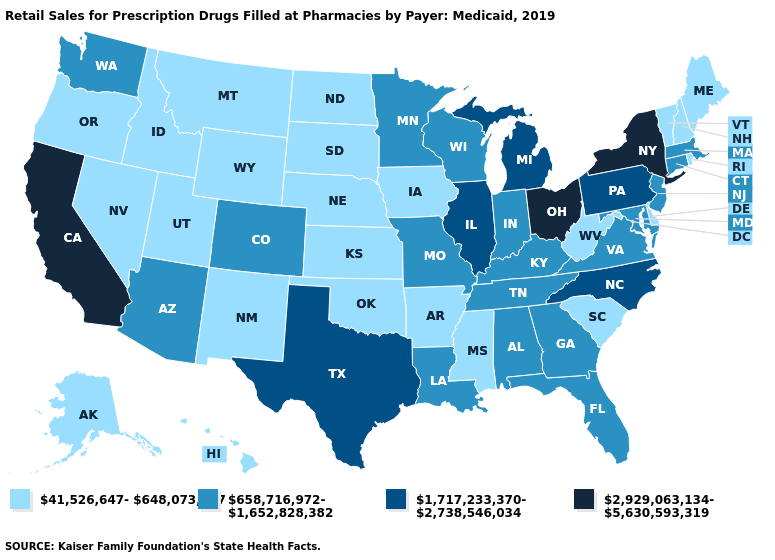Among the states that border Colorado , does Arizona have the highest value?
Quick response, please. Yes. Does South Carolina have the lowest value in the South?
Concise answer only. Yes. Which states have the highest value in the USA?
Keep it brief. California, New York, Ohio. What is the value of North Carolina?
Short answer required. 1,717,233,370-2,738,546,034. Which states have the highest value in the USA?
Keep it brief. California, New York, Ohio. Does New Mexico have a higher value than North Carolina?
Quick response, please. No. Among the states that border Colorado , which have the lowest value?
Keep it brief. Kansas, Nebraska, New Mexico, Oklahoma, Utah, Wyoming. Name the states that have a value in the range 1,717,233,370-2,738,546,034?
Write a very short answer. Illinois, Michigan, North Carolina, Pennsylvania, Texas. Among the states that border Mississippi , does Arkansas have the lowest value?
Quick response, please. Yes. Name the states that have a value in the range 658,716,972-1,652,828,382?
Write a very short answer. Alabama, Arizona, Colorado, Connecticut, Florida, Georgia, Indiana, Kentucky, Louisiana, Maryland, Massachusetts, Minnesota, Missouri, New Jersey, Tennessee, Virginia, Washington, Wisconsin. Does Kentucky have the highest value in the USA?
Concise answer only. No. How many symbols are there in the legend?
Keep it brief. 4. Does California have the same value as Michigan?
Short answer required. No. What is the value of Idaho?
Be succinct. 41,526,647-648,073,297. What is the value of Maine?
Concise answer only. 41,526,647-648,073,297. 